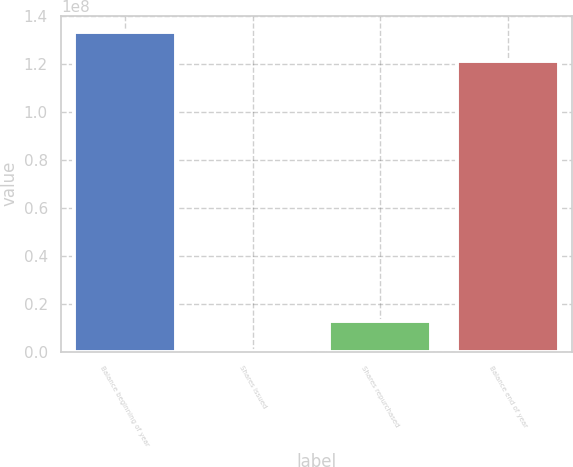<chart> <loc_0><loc_0><loc_500><loc_500><bar_chart><fcel>Balance beginning of year<fcel>Shares issued<fcel>Shares repurchased<fcel>Balance end of year<nl><fcel>1.33496e+08<fcel>281654<fcel>1.25843e+07<fcel>1.21194e+08<nl></chart> 